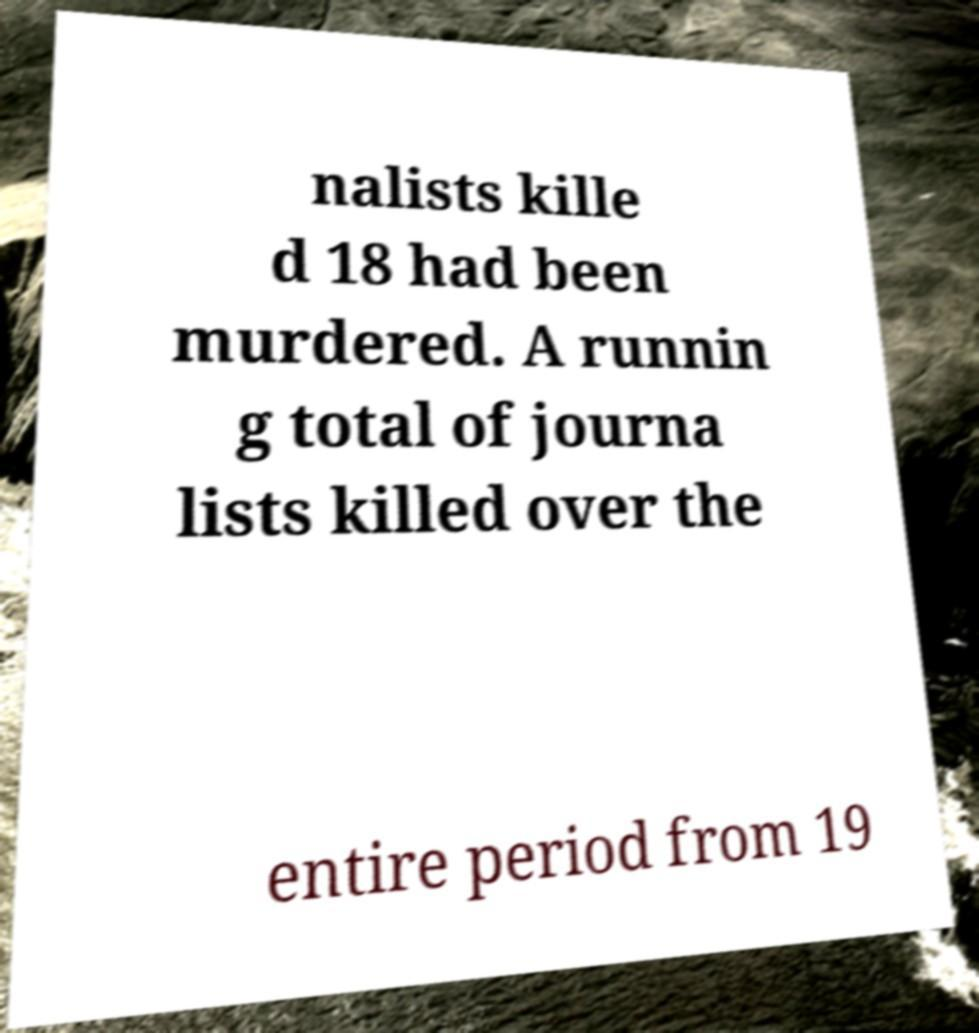Can you read and provide the text displayed in the image?This photo seems to have some interesting text. Can you extract and type it out for me? nalists kille d 18 had been murdered. A runnin g total of journa lists killed over the entire period from 19 